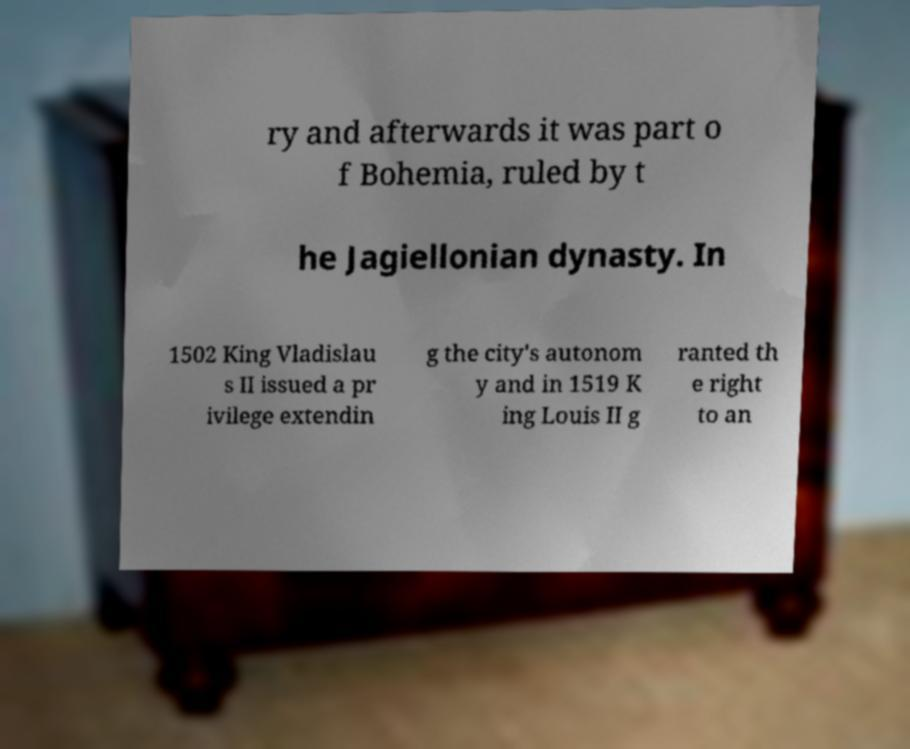Can you read and provide the text displayed in the image?This photo seems to have some interesting text. Can you extract and type it out for me? ry and afterwards it was part o f Bohemia, ruled by t he Jagiellonian dynasty. In 1502 King Vladislau s II issued a pr ivilege extendin g the city's autonom y and in 1519 K ing Louis II g ranted th e right to an 